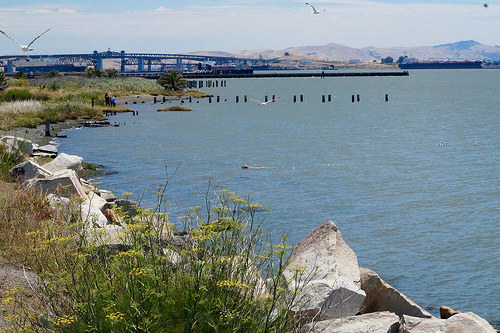<image>
Is the rock to the right of the bridge? No. The rock is not to the right of the bridge. The horizontal positioning shows a different relationship. 